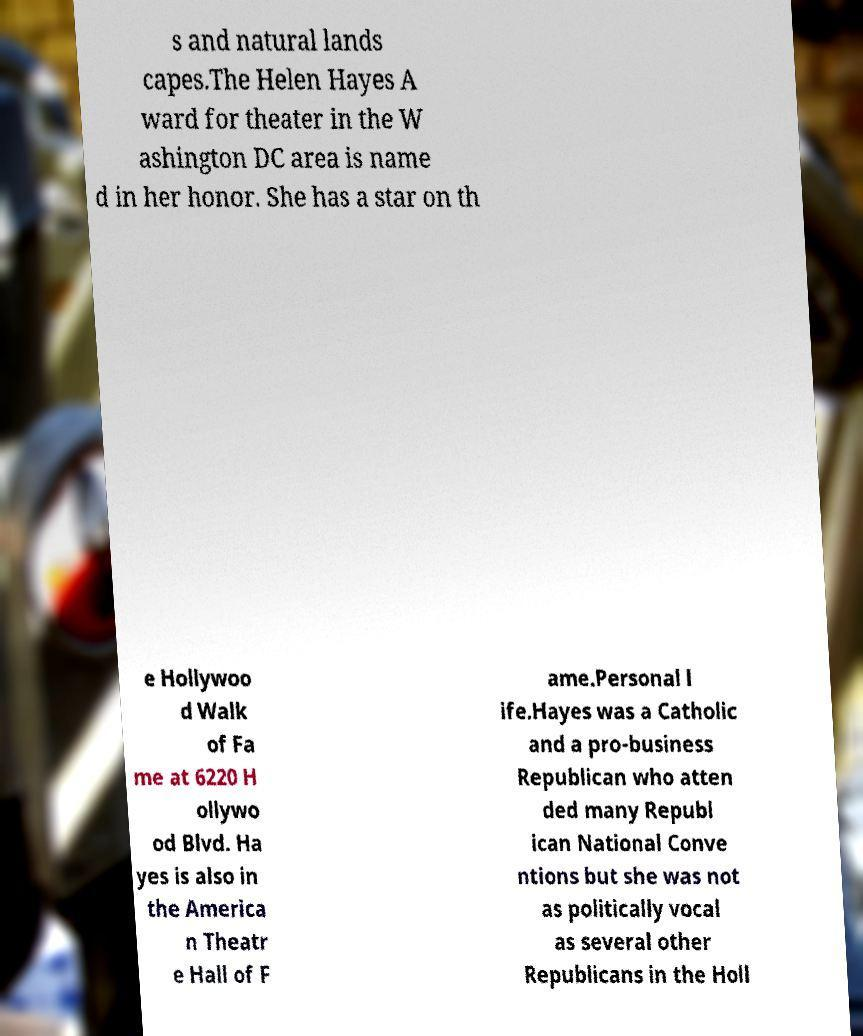Could you extract and type out the text from this image? s and natural lands capes.The Helen Hayes A ward for theater in the W ashington DC area is name d in her honor. She has a star on th e Hollywoo d Walk of Fa me at 6220 H ollywo od Blvd. Ha yes is also in the America n Theatr e Hall of F ame.Personal l ife.Hayes was a Catholic and a pro-business Republican who atten ded many Republ ican National Conve ntions but she was not as politically vocal as several other Republicans in the Holl 